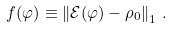Convert formula to latex. <formula><loc_0><loc_0><loc_500><loc_500>f ( \varphi ) \equiv \left \| \mathcal { E } ( \varphi ) - \rho _ { 0 } \right \| _ { 1 } \, .</formula> 